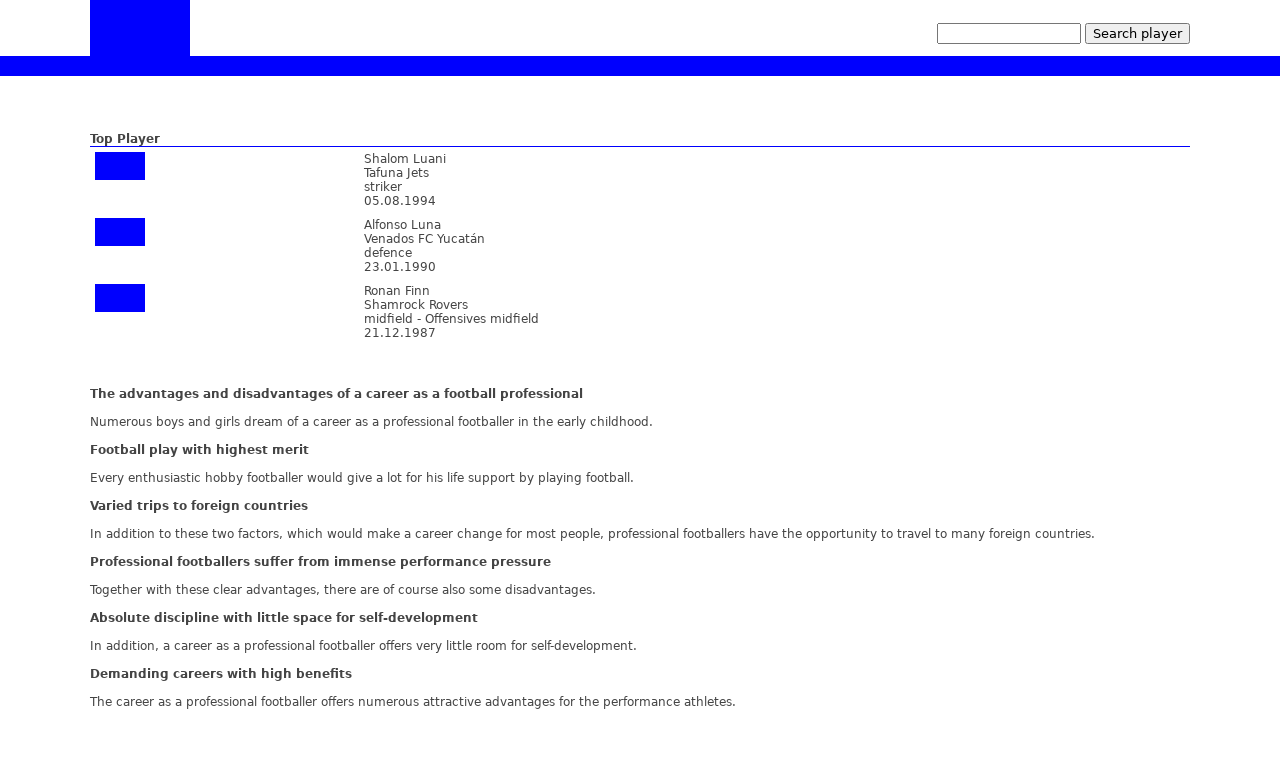Could you detail the process for assembling this website using HTML? Assembling a website using HTML involves several steps, starting from defining the document type and html structure, setting up the head section with all necessary metadata, and configuring the body where all content resides. For the displayed website, you might set it up using the following steps: 1. Start with <!DOCTYPE html> to define the HTML version. 2. Create the html tag and inside it, include the head section where you define the title, link stylesheets, and set meta tags for responsive design. 3. The body section comes next where you structure the website using containers like div for organization. You might use a table layout to align items as seen in the image. 4. Utilize CSS within a style tag to style elements, manage layouts, and emphasize responsiveness. 5. Embed images and setup forms for user interactions such as search functionalities. Remember to test your website in different browsers to ensure compatibility and responsiveness. 